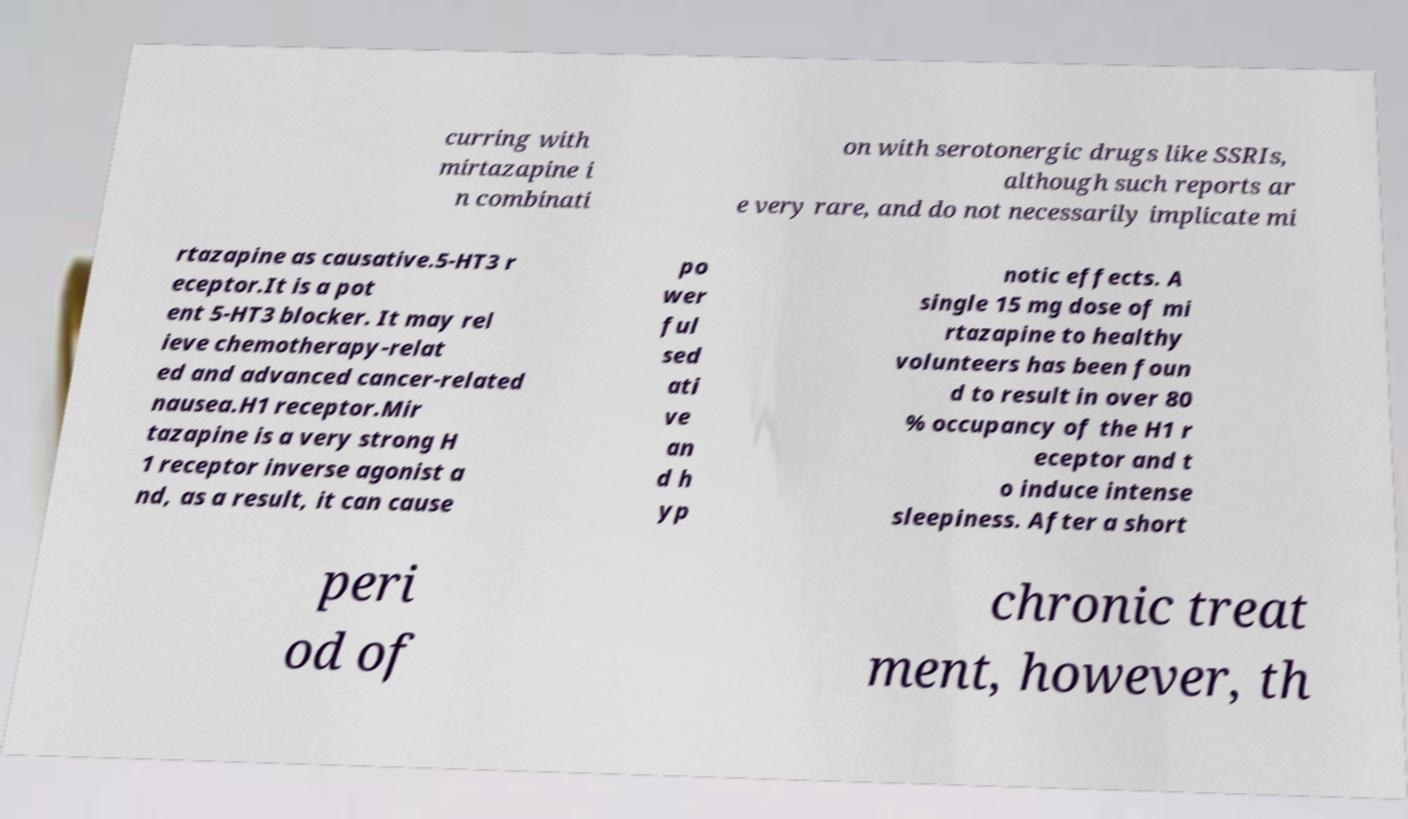Please identify and transcribe the text found in this image. curring with mirtazapine i n combinati on with serotonergic drugs like SSRIs, although such reports ar e very rare, and do not necessarily implicate mi rtazapine as causative.5-HT3 r eceptor.It is a pot ent 5-HT3 blocker. It may rel ieve chemotherapy-relat ed and advanced cancer-related nausea.H1 receptor.Mir tazapine is a very strong H 1 receptor inverse agonist a nd, as a result, it can cause po wer ful sed ati ve an d h yp notic effects. A single 15 mg dose of mi rtazapine to healthy volunteers has been foun d to result in over 80 % occupancy of the H1 r eceptor and t o induce intense sleepiness. After a short peri od of chronic treat ment, however, th 